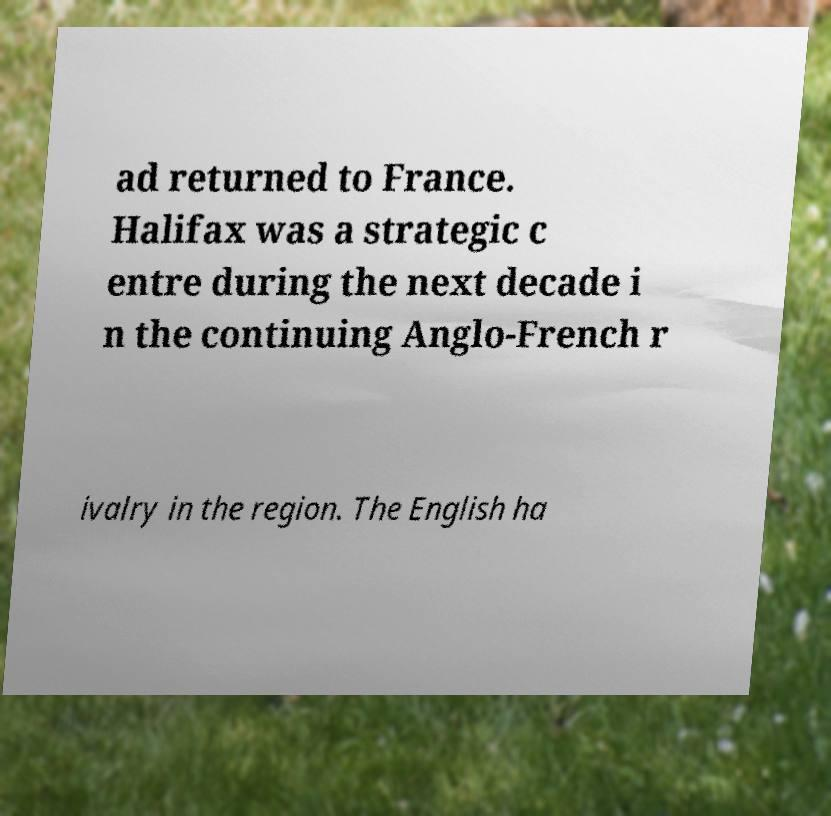What messages or text are displayed in this image? I need them in a readable, typed format. ad returned to France. Halifax was a strategic c entre during the next decade i n the continuing Anglo-French r ivalry in the region. The English ha 